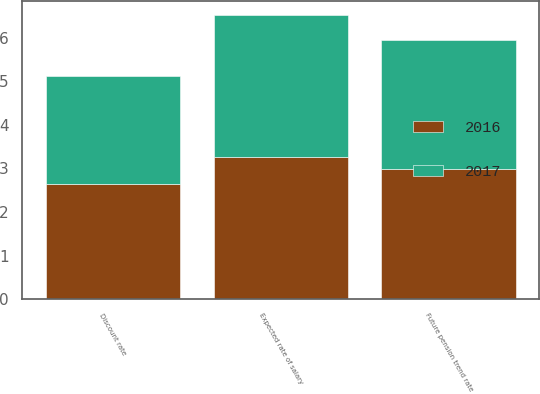<chart> <loc_0><loc_0><loc_500><loc_500><stacked_bar_chart><ecel><fcel>Discount rate<fcel>Expected rate of salary<fcel>Future pension trend rate<nl><fcel>2017<fcel>2.47<fcel>3.26<fcel>2.97<nl><fcel>2016<fcel>2.64<fcel>3.26<fcel>2.98<nl></chart> 